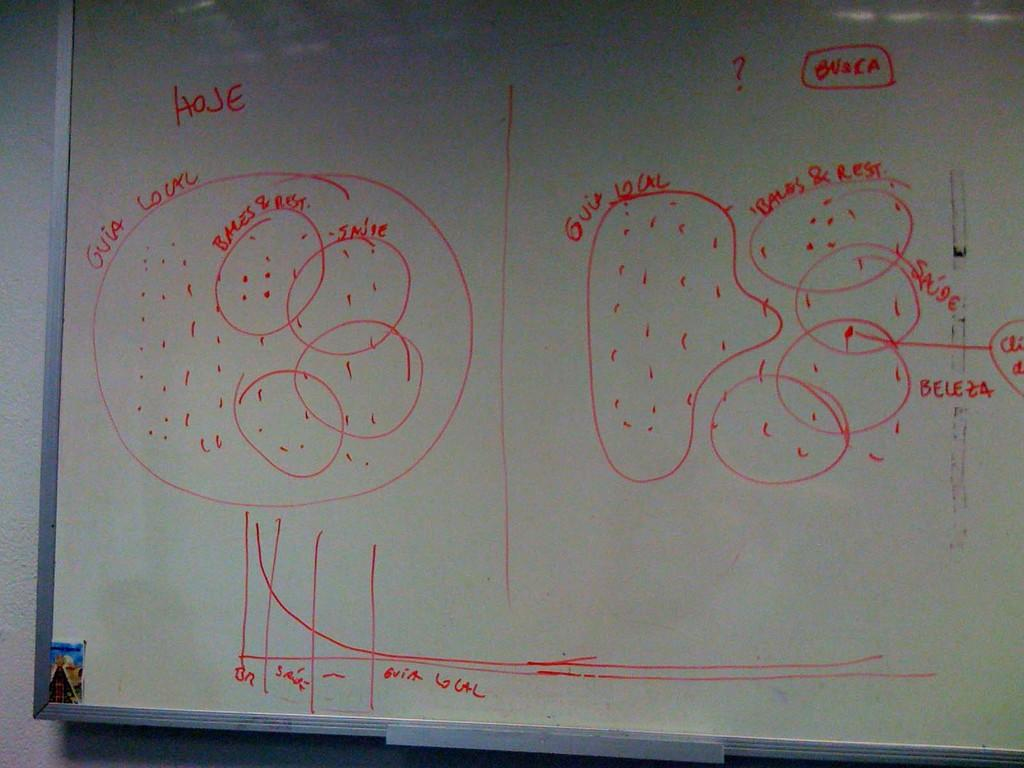<image>
Summarize the visual content of the image. A white dry erase board with red inked diagram and graph depicting Hoje and Buaca. 